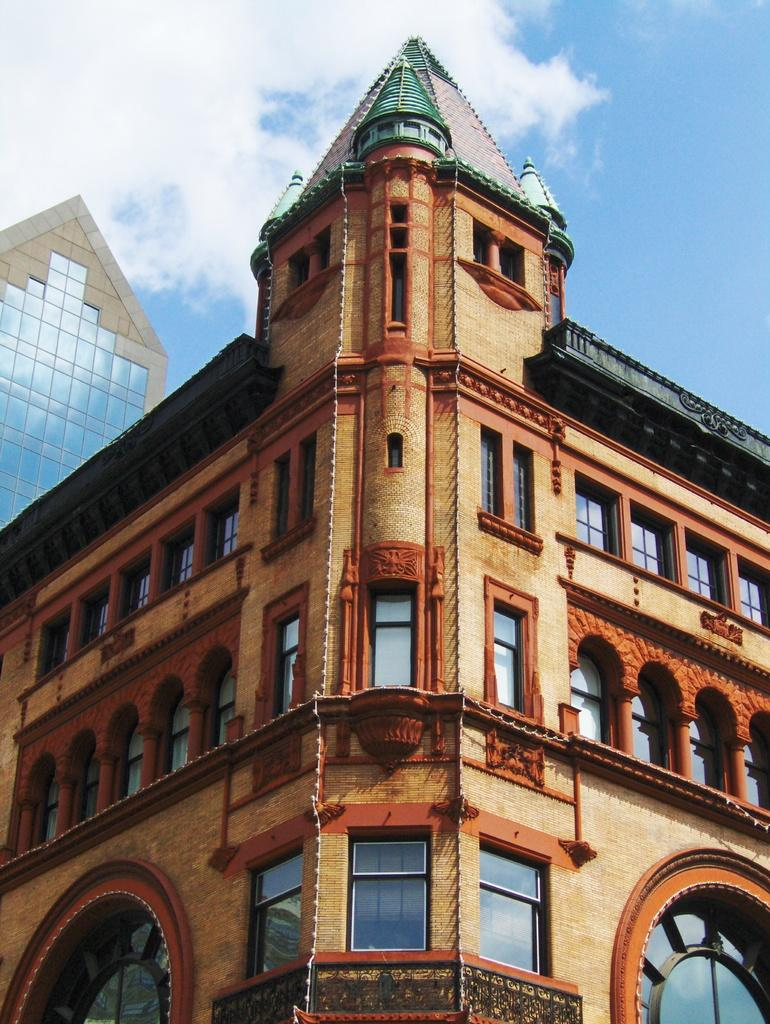What type of structure is in the picture? There is a building in the picture. What can be seen above the building? The sky is visible at the top of the picture. What is present in the sky? Clouds are present in the sky. What features can be observed on the building? There are windows and glasses (possibly referring to glass panes) in the building. How does the worm interact with the building in the image? There is no worm present in the image, so it cannot interact with the building. 